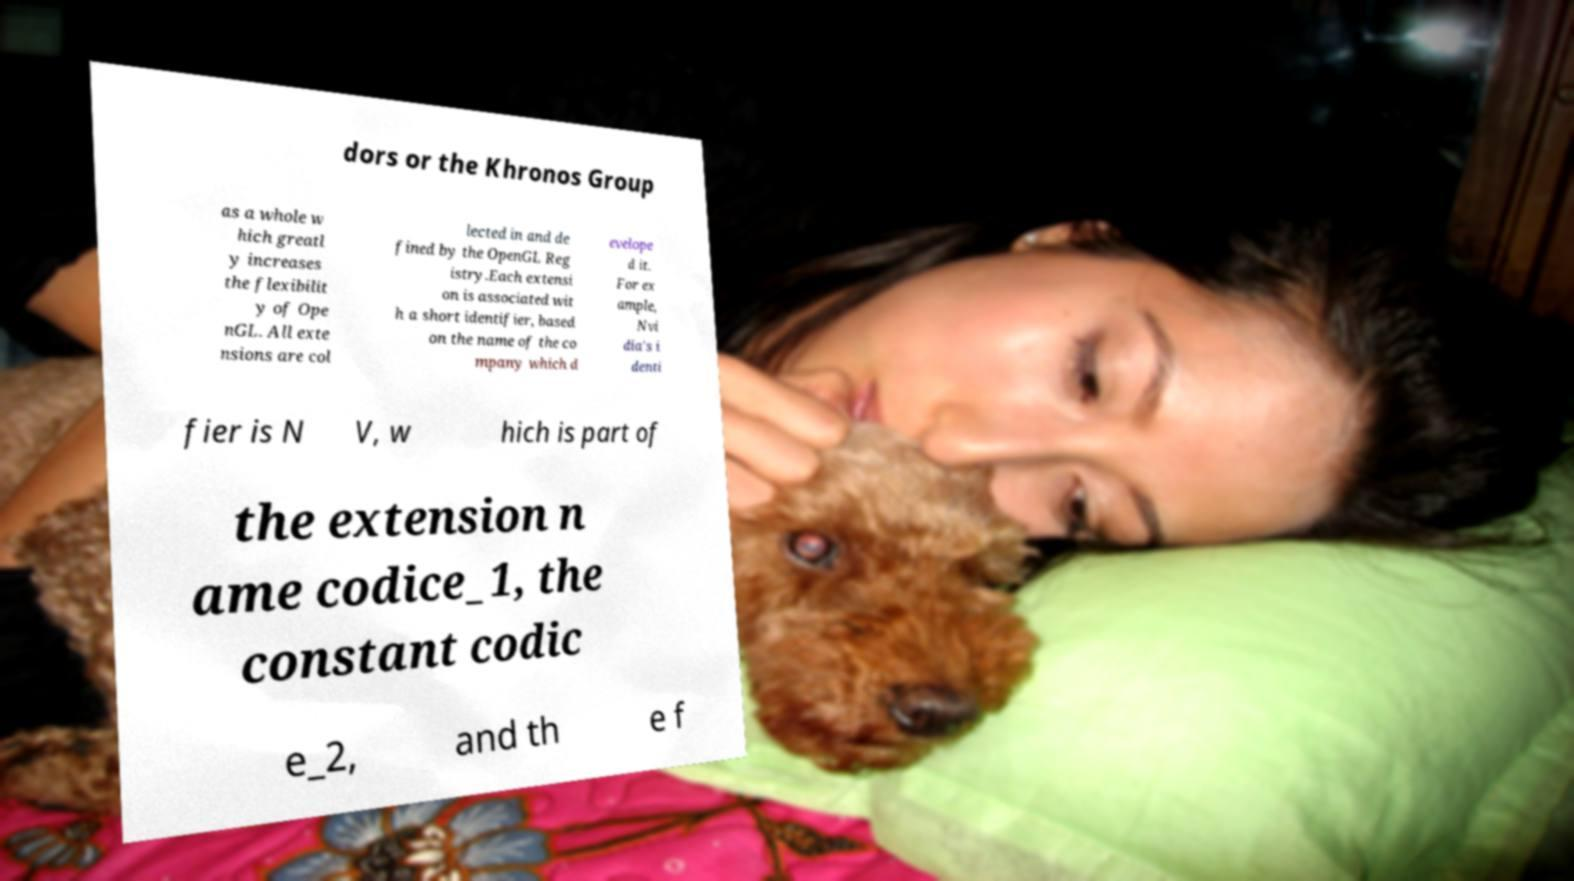Could you extract and type out the text from this image? dors or the Khronos Group as a whole w hich greatl y increases the flexibilit y of Ope nGL. All exte nsions are col lected in and de fined by the OpenGL Reg istry.Each extensi on is associated wit h a short identifier, based on the name of the co mpany which d evelope d it. For ex ample, Nvi dia's i denti fier is N V, w hich is part of the extension n ame codice_1, the constant codic e_2, and th e f 